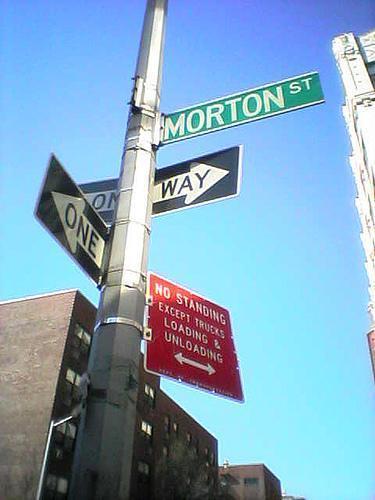How many sign are there?
Give a very brief answer. 4. 